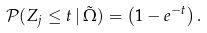Convert formula to latex. <formula><loc_0><loc_0><loc_500><loc_500>\mathcal { P } ( Z _ { j } \leq t \, | \, \tilde { \Omega } ) = \left ( 1 - e ^ { - t } \right ) .</formula> 